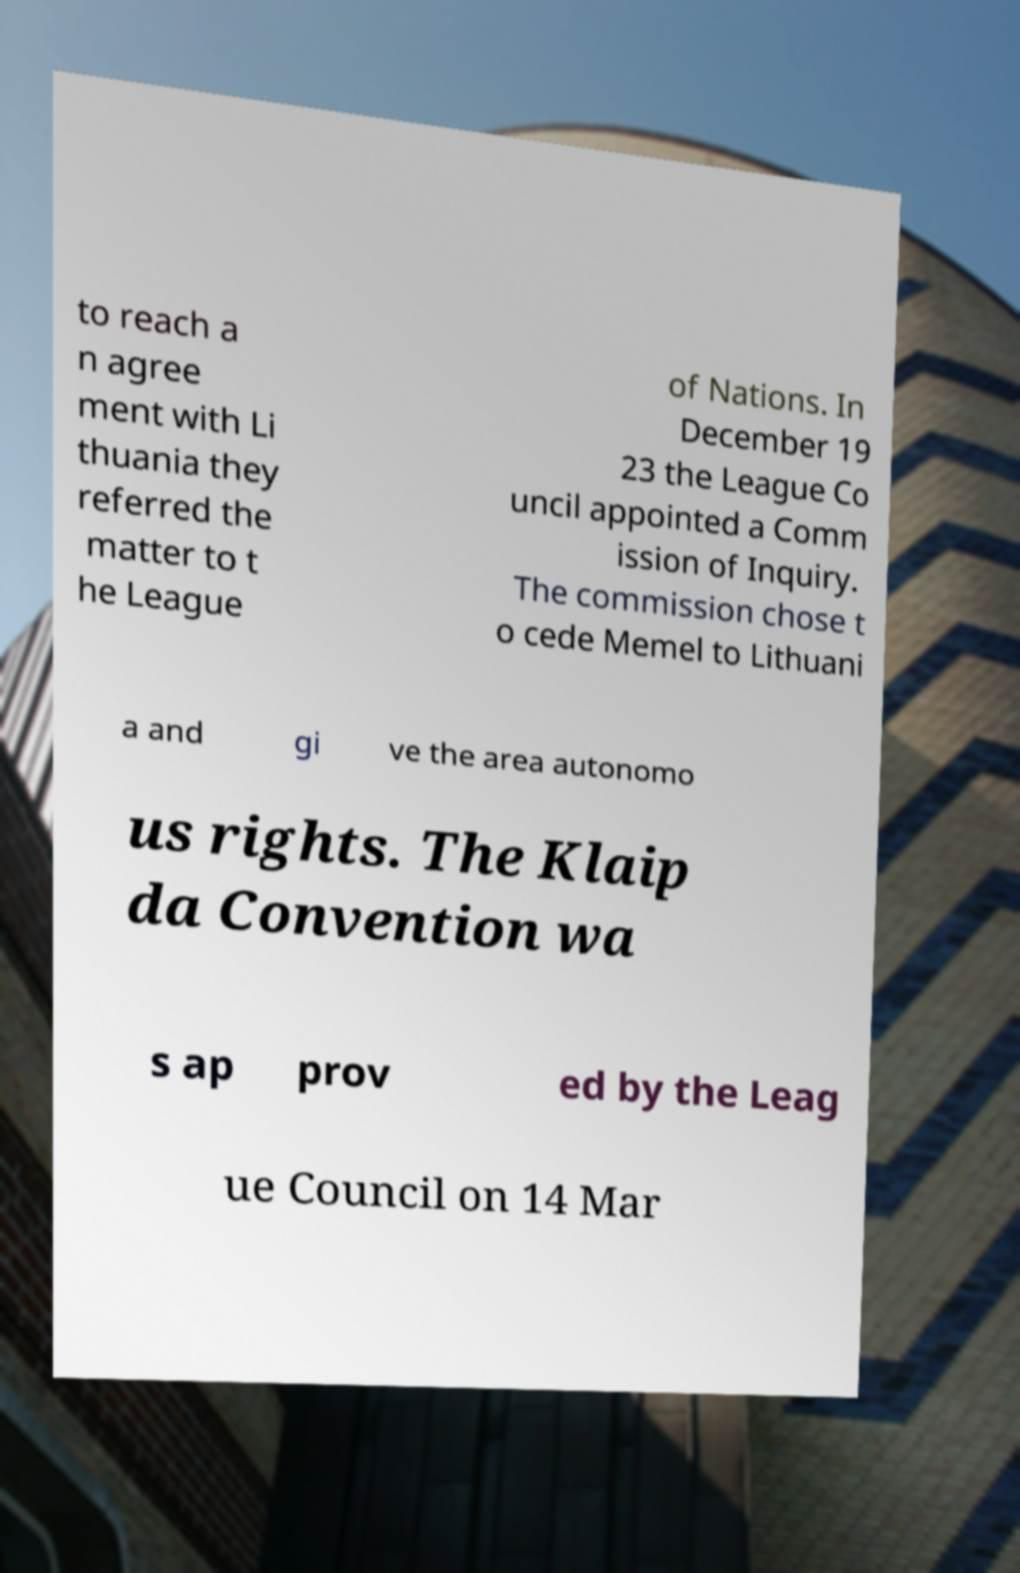Please identify and transcribe the text found in this image. to reach a n agree ment with Li thuania they referred the matter to t he League of Nations. In December 19 23 the League Co uncil appointed a Comm ission of Inquiry. The commission chose t o cede Memel to Lithuani a and gi ve the area autonomo us rights. The Klaip da Convention wa s ap prov ed by the Leag ue Council on 14 Mar 